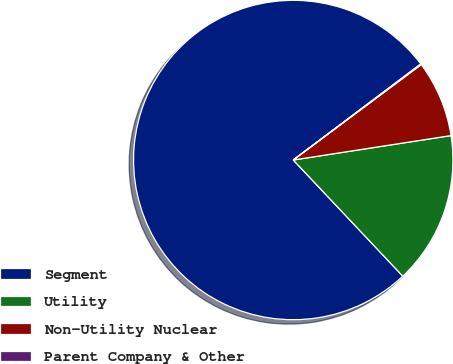Convert chart to OTSL. <chart><loc_0><loc_0><loc_500><loc_500><pie_chart><fcel>Segment<fcel>Utility<fcel>Non-Utility Nuclear<fcel>Parent Company & Other<nl><fcel>76.76%<fcel>15.41%<fcel>7.75%<fcel>0.08%<nl></chart> 